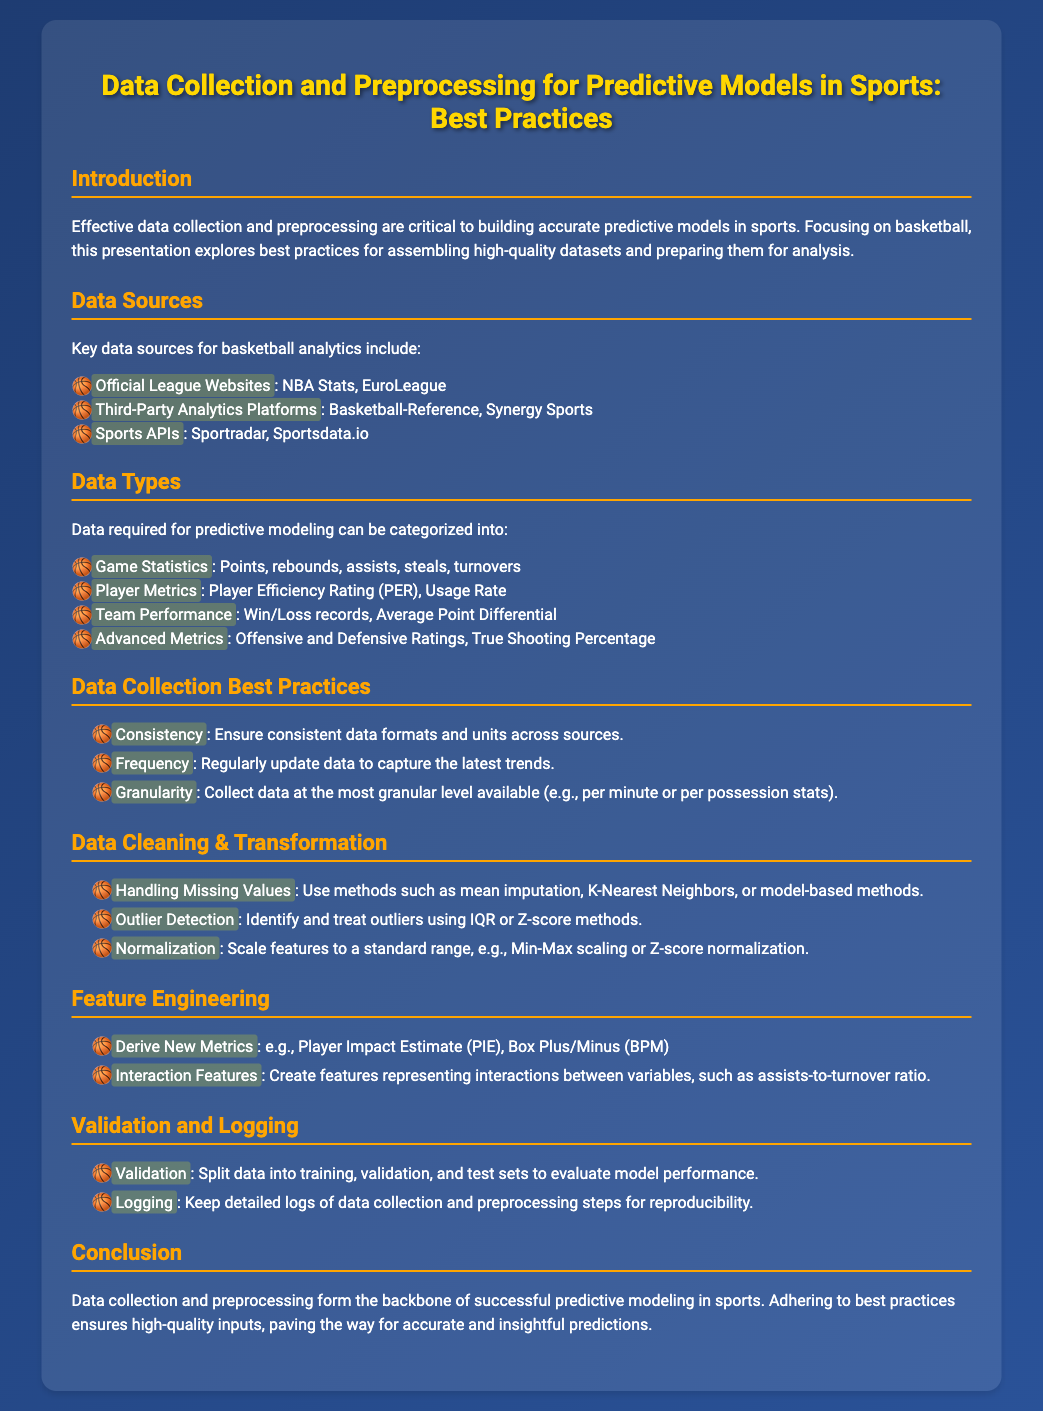What are key data sources for basketball analytics? The document lists specific data sources, including official league websites, third-party analytics platforms, and sports APIs relevant to basketball analytics.
Answer: Official League Websites, Third-Party Analytics Platforms, Sports APIs What is one type of data required for predictive modeling? The document categorizes data types needed for predictive modeling and specifies game statistics, player metrics, team performance, and advanced metrics.
Answer: Game Statistics What is mentioned as a data cleaning method? The document provides several methods for handling missing values, highlighting various approaches to data cleaning that are crucial for accuracy.
Answer: Mean imputation What is a focus of feature engineering according to the presentation? The document emphasizes deriving new metrics and creating interaction features as part of the feature engineering process for predictive modeling.
Answer: Derive New Metrics How many sections are in the presentation? By counting the distinct sections presented in the document, we can determine the total number of key areas addressed.
Answer: Eight What is the primary goal of data collection and preprocessing? The conclusion section summarizes the overarching purpose of effective data practices in predictive modeling within sports context.
Answer: Accurate and insightful predictions What is a practice for data collection mentioned in the document? The document offers several best practices for data collection and emphasizes the importance of criteria like consistency, frequency, and granularity.
Answer: Consistency What should be kept for reproducibility during data collection? The document stresses the need for maintaining detailed documentation of the processes involved in data collection and preprocessing for validity.
Answer: Detailed logs 